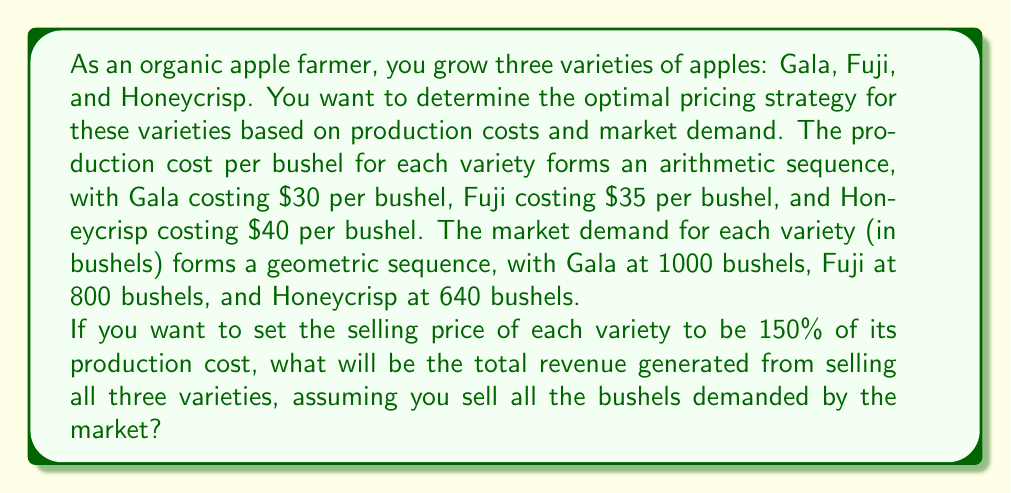Give your solution to this math problem. Let's approach this problem step by step:

1. Identify the sequences:
   - Production costs form an arithmetic sequence: $30, $35, $40
   - Market demand forms a geometric sequence: 1000, 800, 640

2. Calculate the common difference (d) for the arithmetic sequence of production costs:
   $d = 35 - 30 = 40 - 35 = 5$

3. Calculate the common ratio (r) for the geometric sequence of market demand:
   $r = 800 / 1000 = 640 / 800 = 0.8$

4. Set up the selling price for each variety (150% of production cost):
   - Gala: $30 \times 1.5 = $45$ per bushel
   - Fuji: $35 \times 1.5 = $52.50$ per bushel
   - Honeycrisp: $40 \times 1.5 = $60$ per bushel

5. Calculate the revenue for each variety:
   - Gala: $45 \times 1000 = $45,000$
   - Fuji: $52.50 \times 800 = $42,000$
   - Honeycrisp: $60 \times 640 = $38,400$

6. Sum up the total revenue:
   $Total Revenue = $45,000 + $42,000 + $38,400 = $125,400$

We can also express this as a series:
$$Total Revenue = \sum_{n=1}^{3} (30 + 5(n-1)) \times 1.5 \times 1000 \times 0.8^{n-1}$$

Where:
- $(30 + 5(n-1))$ represents the arithmetic sequence of production costs
- $1.5$ is the markup factor
- $1000 \times 0.8^{n-1}$ represents the geometric sequence of market demand
Answer: The total revenue generated from selling all three apple varieties is $125,400. 